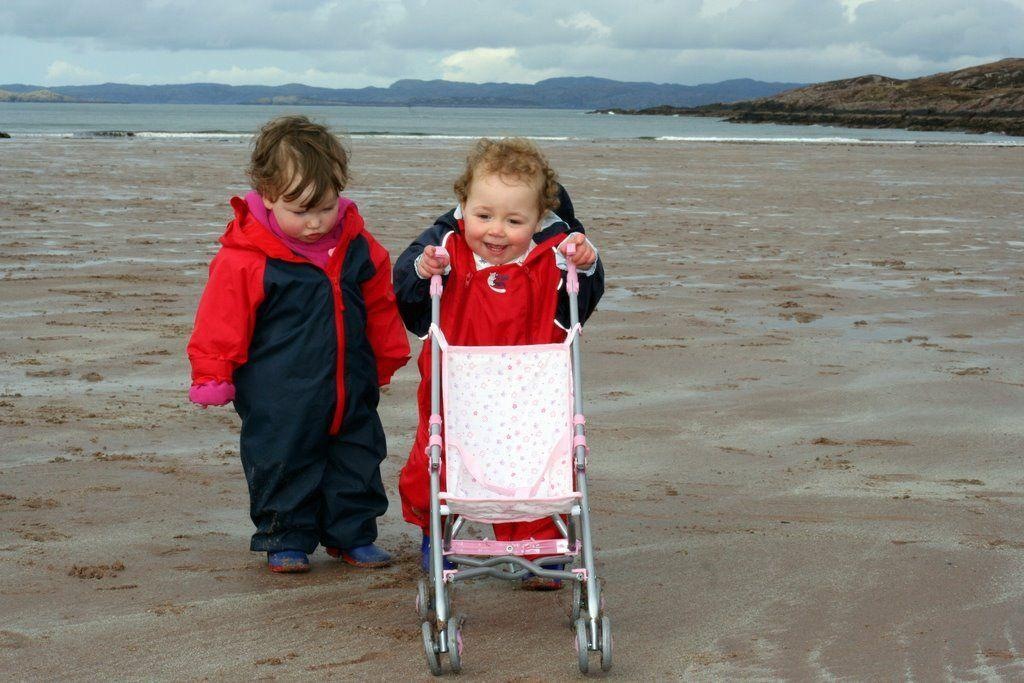How many people are in the image? There are two people in the image. What is one object that can be seen in the image? There is a chair in the image. What can be seen in the background of the image? Water and hills are visible in the background of the image. What is visible at the top of the image? The sky is visible at the top of the image. How many pigs are present in the image? There are no pigs present in the image. What type of system is being used to paste the poster in the image? There is no poster or system visible in the image; it only shows two people, a chair, water, hills, and the sky. 